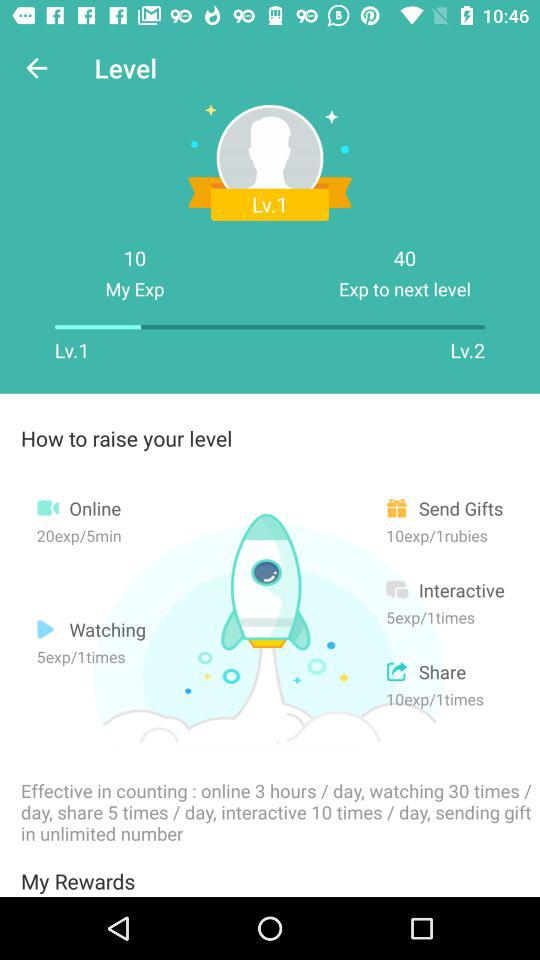What effect does counting have on watching?
When the provided information is insufficient, respond with <no answer>. <no answer> 